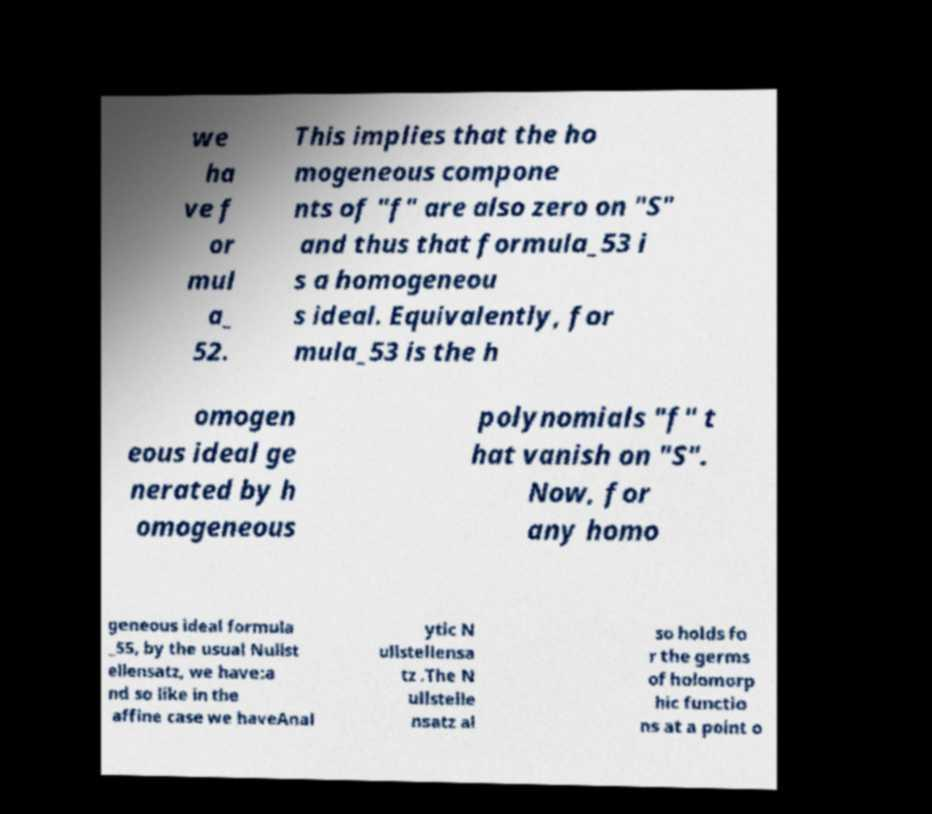Can you read and provide the text displayed in the image?This photo seems to have some interesting text. Can you extract and type it out for me? we ha ve f or mul a_ 52. This implies that the ho mogeneous compone nts of "f" are also zero on "S" and thus that formula_53 i s a homogeneou s ideal. Equivalently, for mula_53 is the h omogen eous ideal ge nerated by h omogeneous polynomials "f" t hat vanish on "S". Now, for any homo geneous ideal formula _55, by the usual Nullst ellensatz, we have:a nd so like in the affine case we haveAnal ytic N ullstellensa tz .The N ullstelle nsatz al so holds fo r the germs of holomorp hic functio ns at a point o 